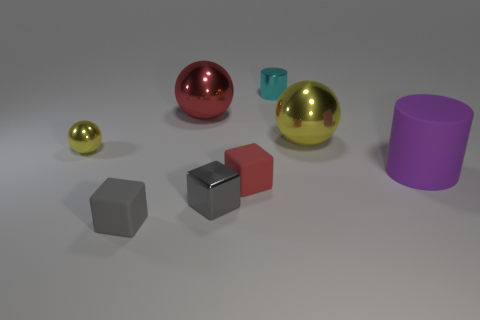There is a metallic cube that is the same size as the cyan object; what color is it?
Offer a terse response. Gray. Does the cyan cylinder have the same material as the red cube?
Offer a terse response. No. What material is the small gray thing behind the small rubber cube on the left side of the metal cube?
Make the answer very short. Metal. Are there more small yellow spheres behind the tiny red rubber cube than cylinders?
Give a very brief answer. No. What number of other objects are there of the same size as the gray rubber cube?
Keep it short and to the point. 4. Does the big cylinder have the same color as the small shiny ball?
Give a very brief answer. No. There is a tiny shiny object that is in front of the yellow metallic sphere that is in front of the yellow ball that is right of the cyan metallic cylinder; what color is it?
Provide a succinct answer. Gray. There is a small shiny object on the right side of the metallic object that is in front of the purple cylinder; what number of cubes are behind it?
Give a very brief answer. 0. Is there any other thing that is the same color as the tiny shiny ball?
Ensure brevity in your answer.  Yes. There is a metal sphere to the right of the red matte object; does it have the same size as the tiny red block?
Provide a succinct answer. No. 